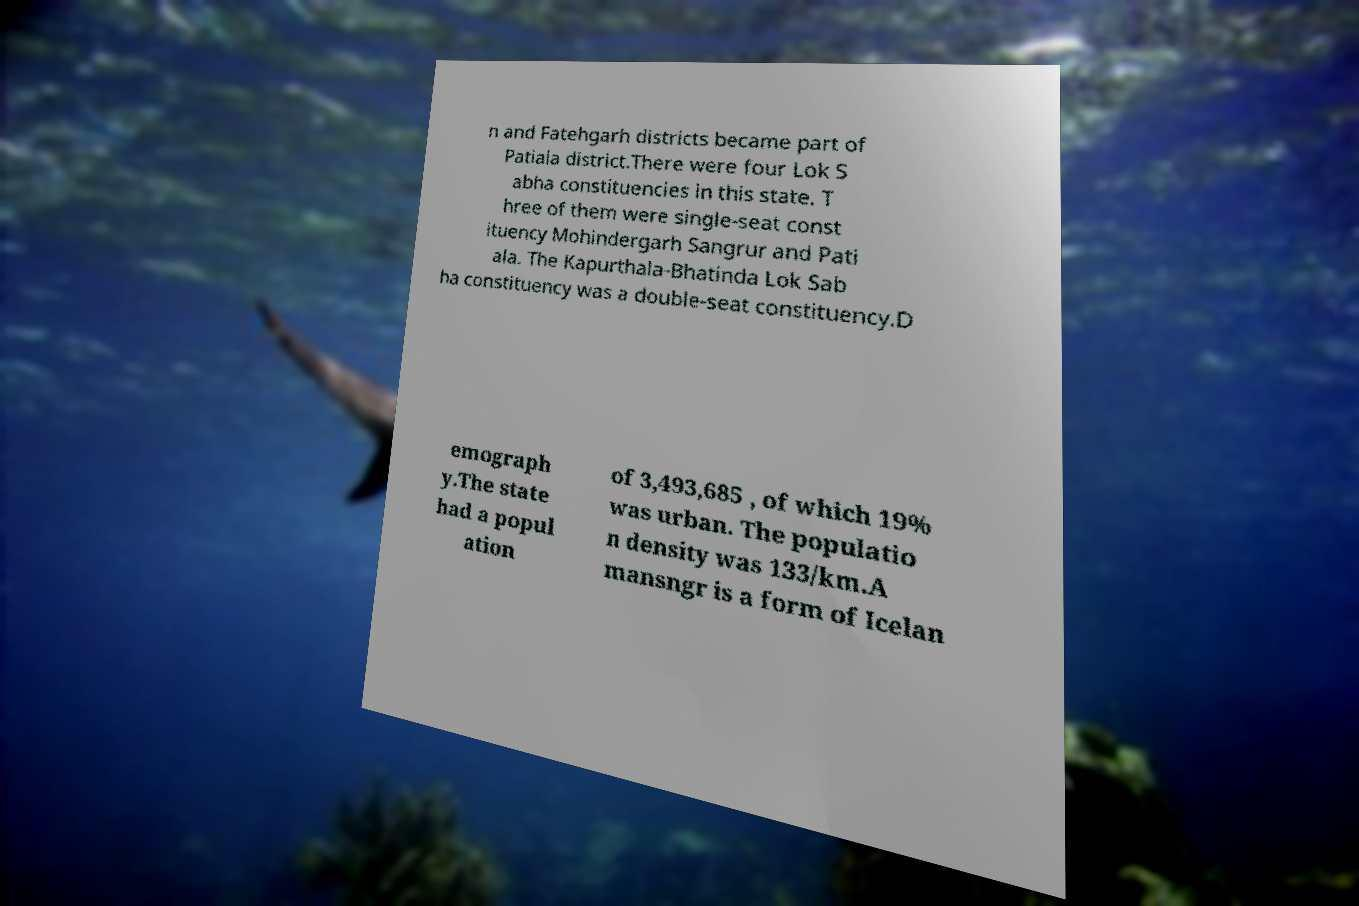What messages or text are displayed in this image? I need them in a readable, typed format. n and Fatehgarh districts became part of Patiala district.There were four Lok S abha constituencies in this state. T hree of them were single-seat const ituency Mohindergarh Sangrur and Pati ala. The Kapurthala-Bhatinda Lok Sab ha constituency was a double-seat constituency.D emograph y.The state had a popul ation of 3,493,685 , of which 19% was urban. The populatio n density was 133/km.A mansngr is a form of Icelan 